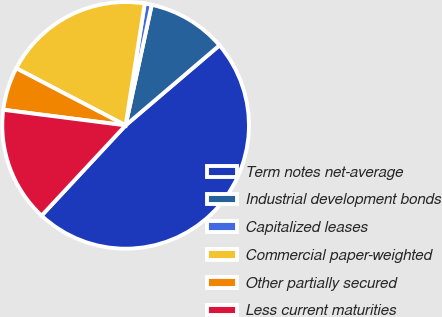Convert chart. <chart><loc_0><loc_0><loc_500><loc_500><pie_chart><fcel>Term notes net-average<fcel>Industrial development bonds<fcel>Capitalized leases<fcel>Commercial paper-weighted<fcel>Other partially secured<fcel>Less current maturities<nl><fcel>48.17%<fcel>10.37%<fcel>0.92%<fcel>19.82%<fcel>5.64%<fcel>15.09%<nl></chart> 